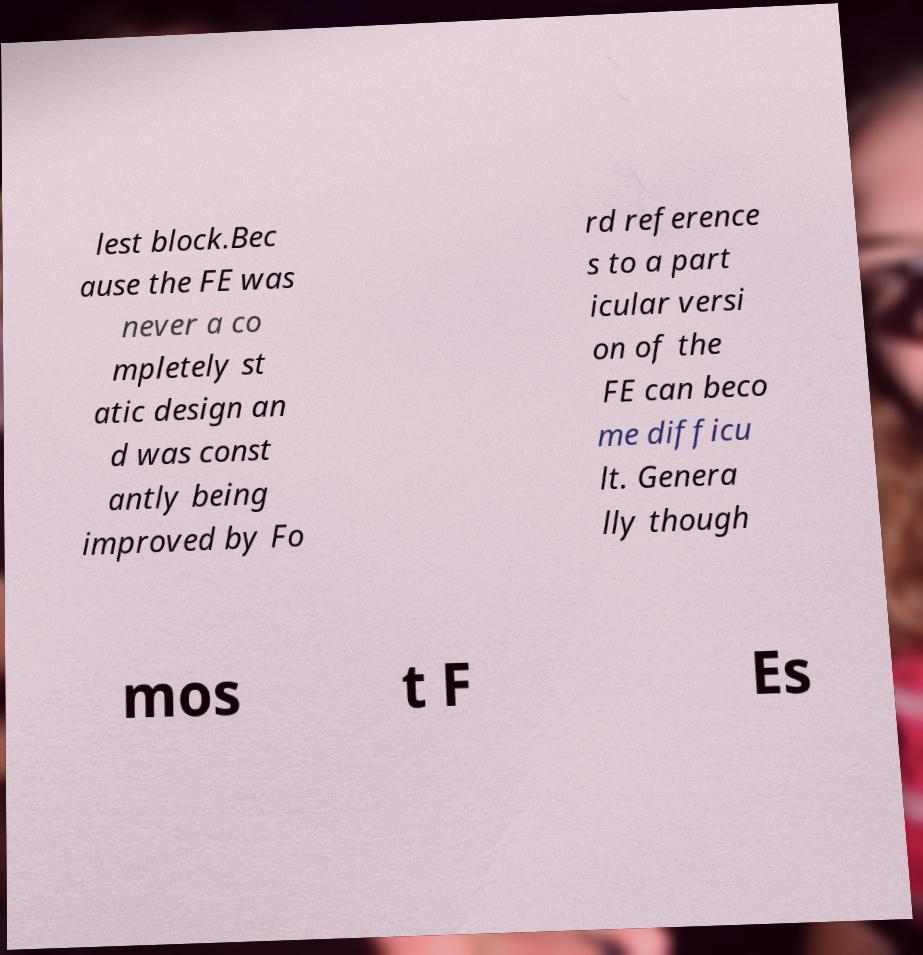Please identify and transcribe the text found in this image. lest block.Bec ause the FE was never a co mpletely st atic design an d was const antly being improved by Fo rd reference s to a part icular versi on of the FE can beco me difficu lt. Genera lly though mos t F Es 